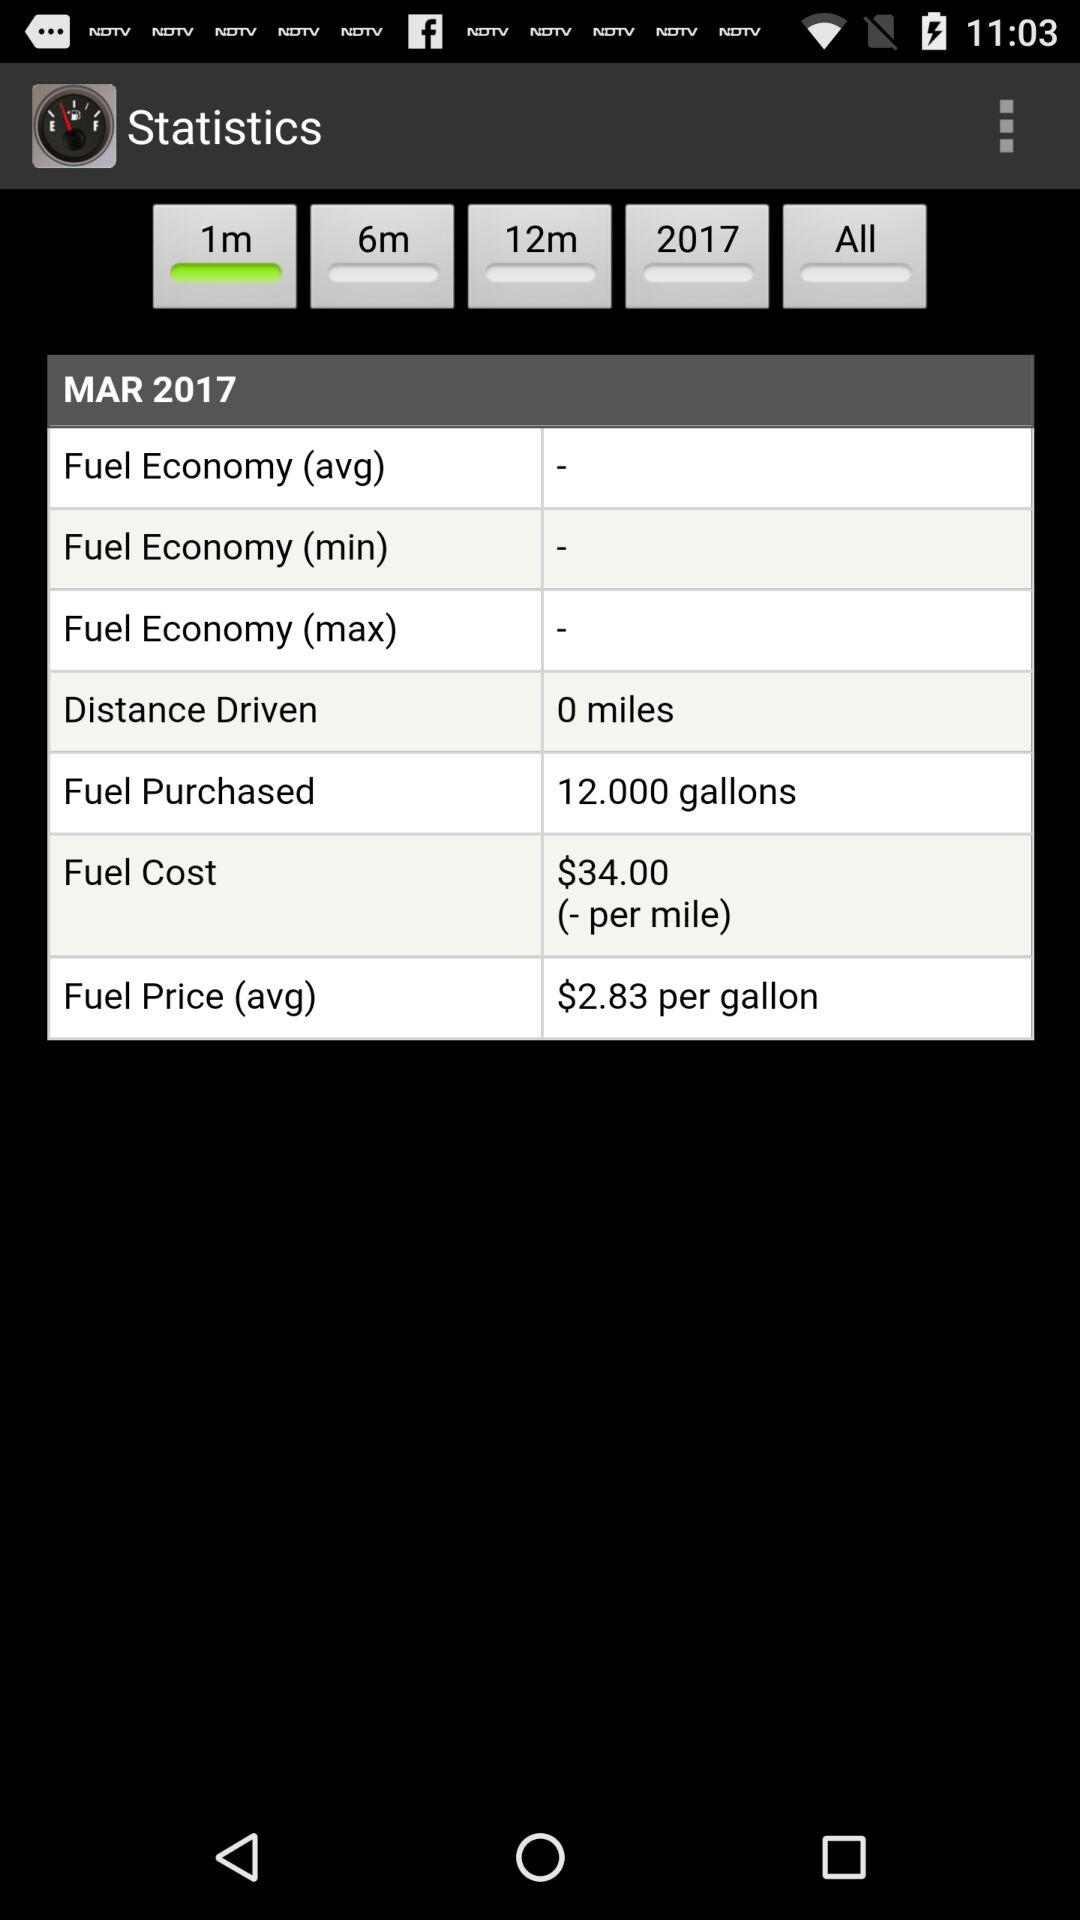Which distance is selected? The selected distance is 1m. 